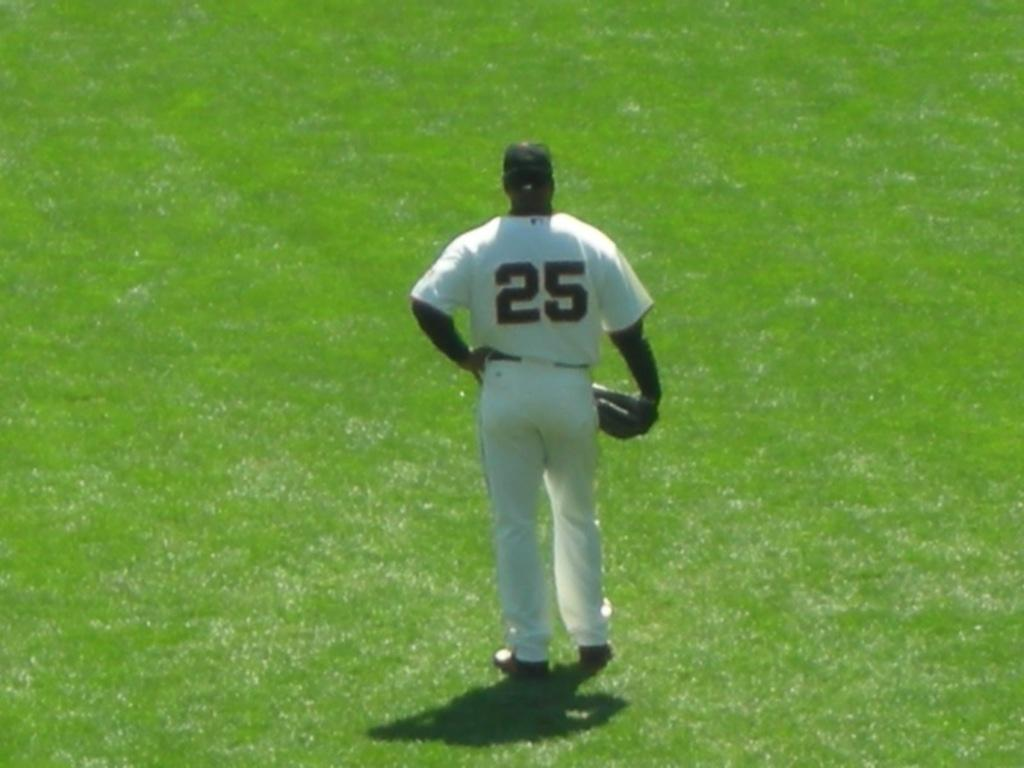<image>
Write a terse but informative summary of the picture. The baseball player's shirt is number twenty five. 